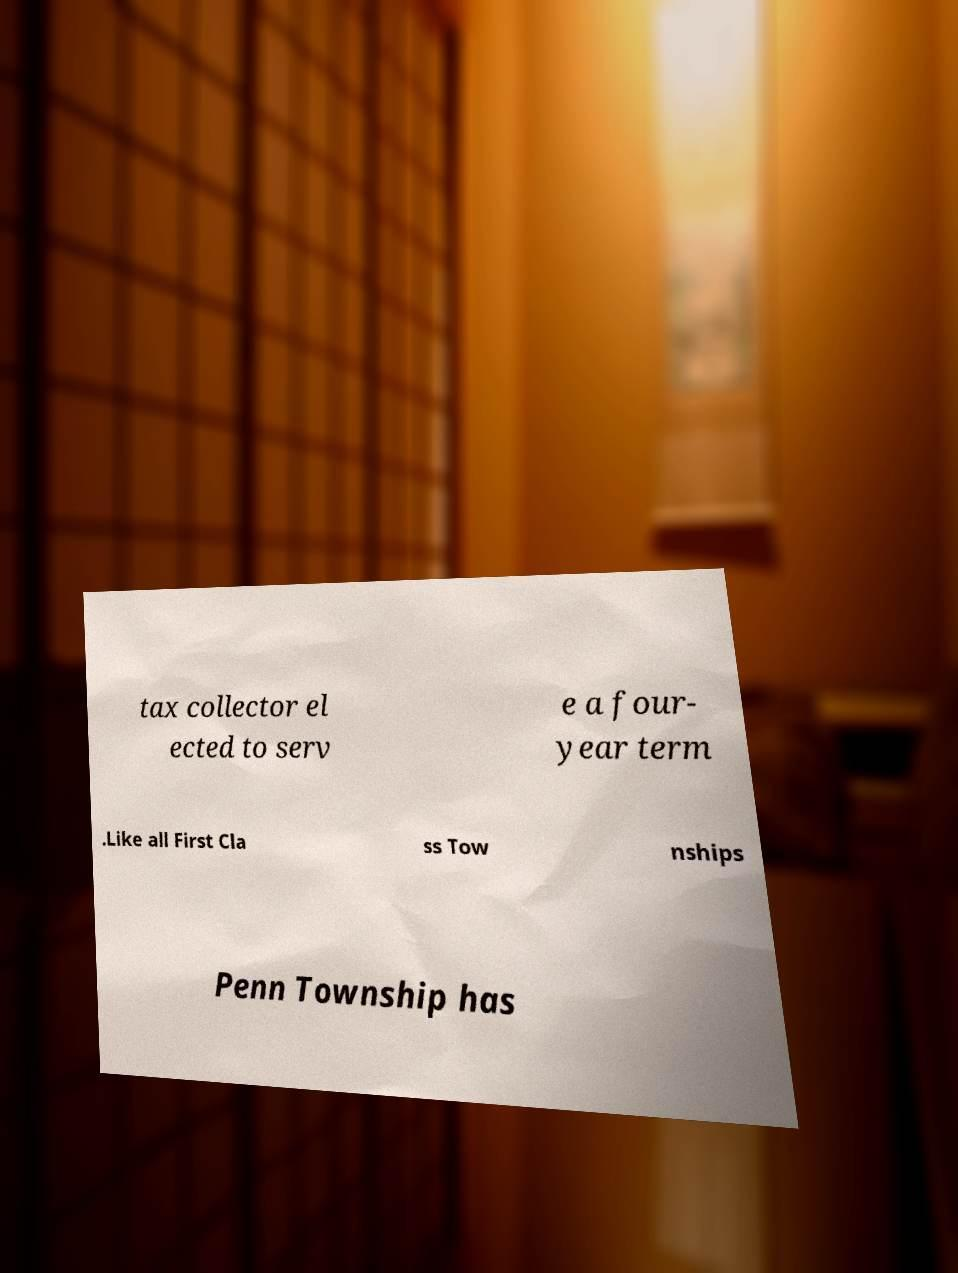Please read and relay the text visible in this image. What does it say? tax collector el ected to serv e a four- year term .Like all First Cla ss Tow nships Penn Township has 